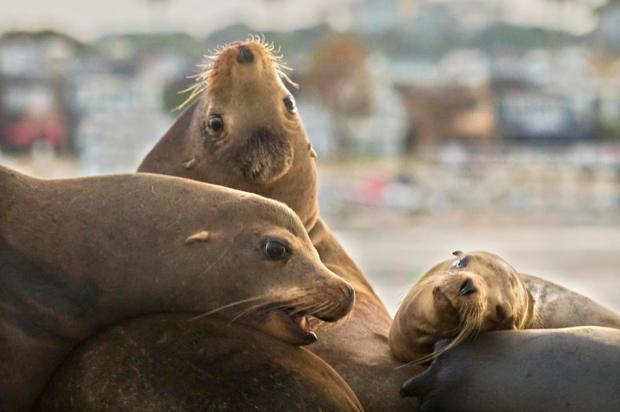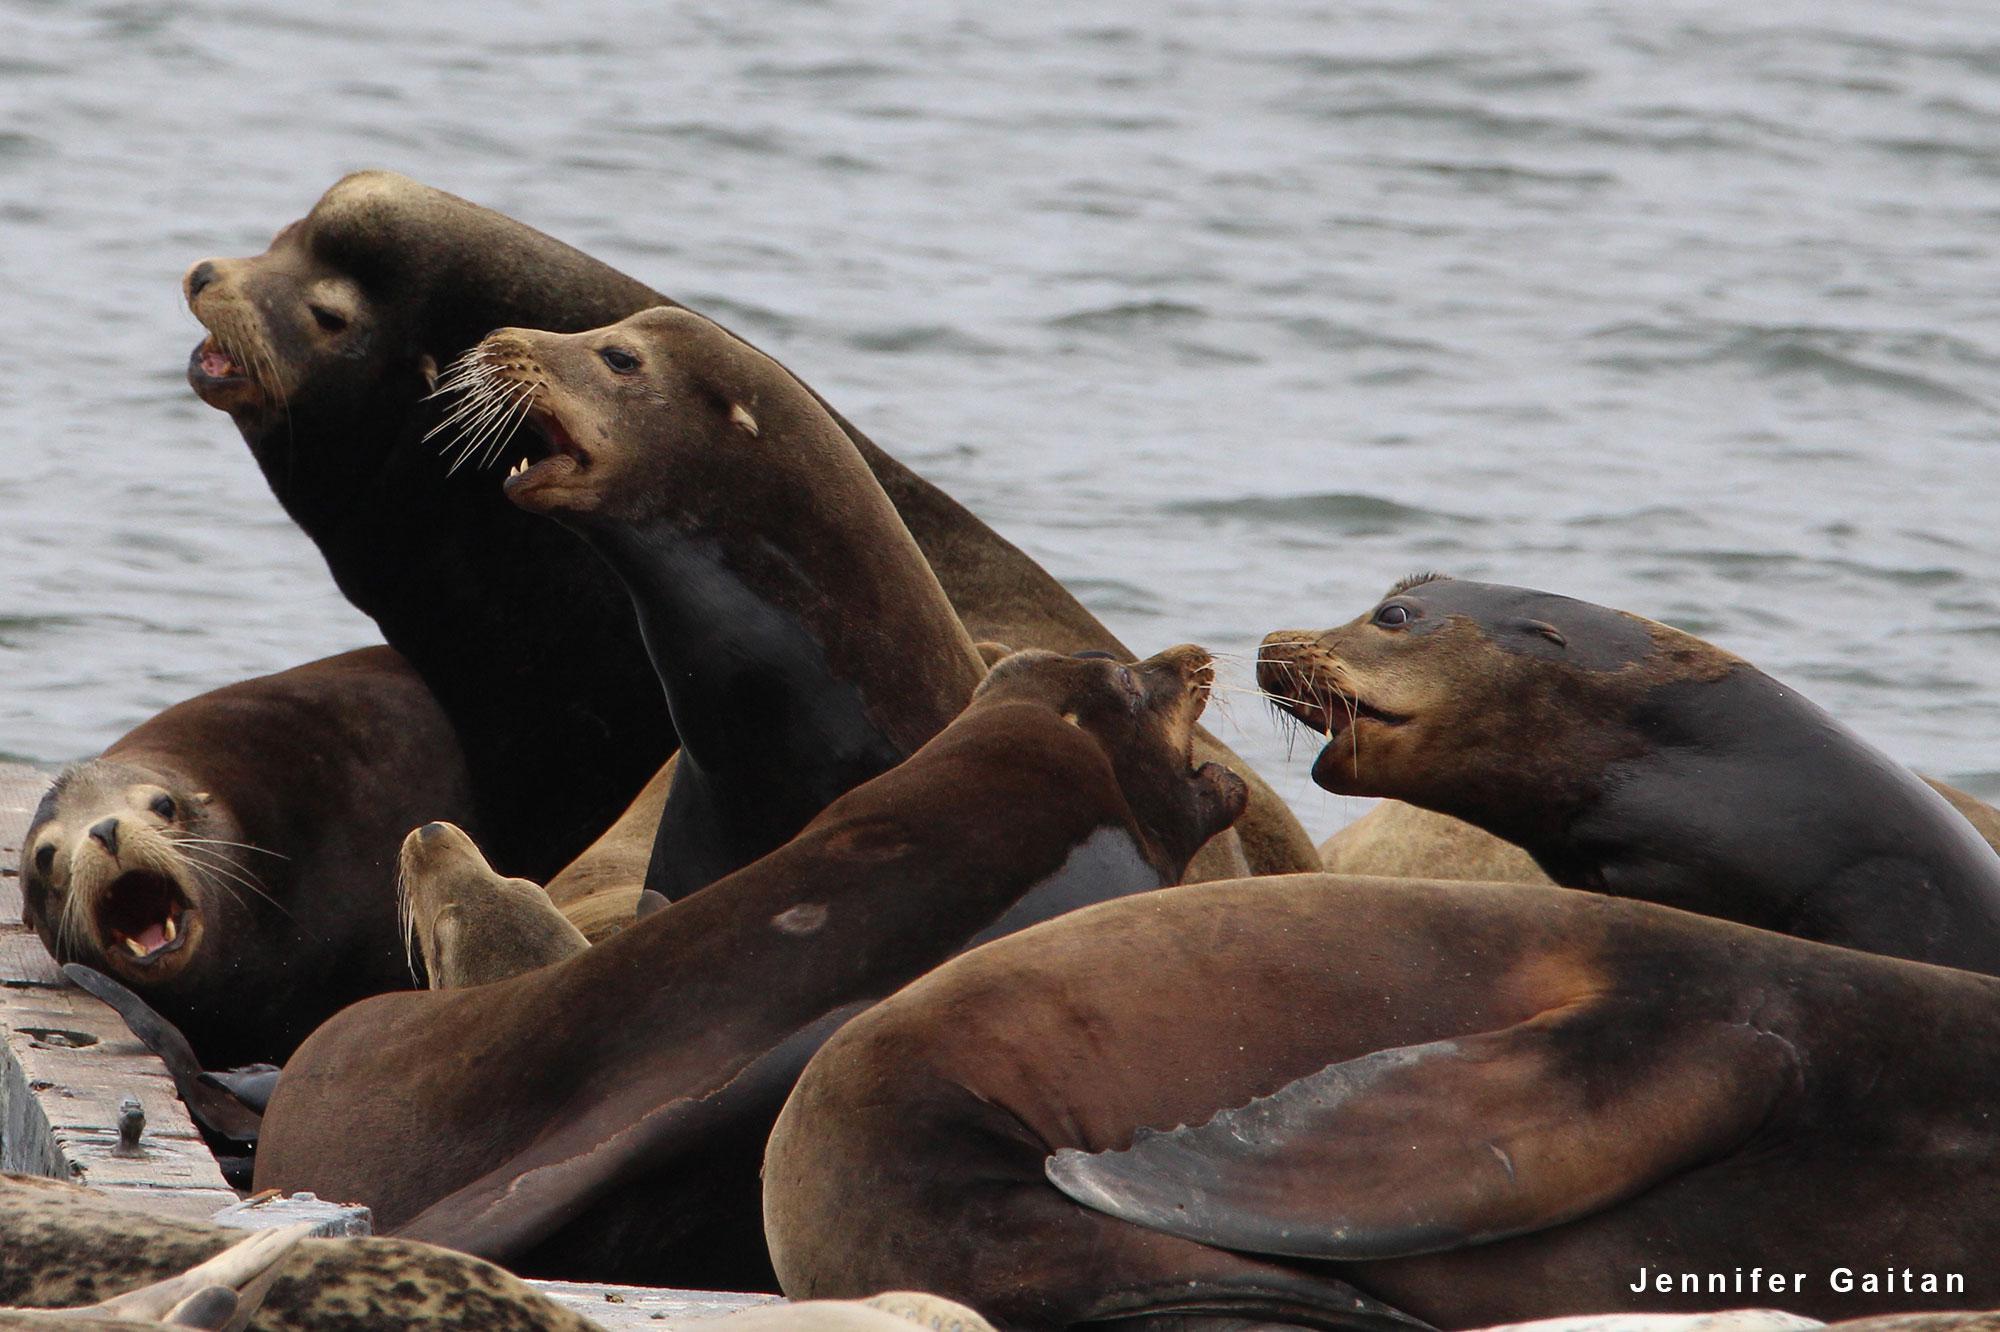The first image is the image on the left, the second image is the image on the right. Examine the images to the left and right. Is the description "An image shows one large seal with raised head amidst multiple smaller seals." accurate? Answer yes or no. No. 